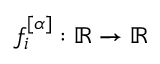Convert formula to latex. <formula><loc_0><loc_0><loc_500><loc_500>f _ { i } ^ { [ \alpha ] } \colon \mathbb { R } \rightarrow \mathbb { R }</formula> 